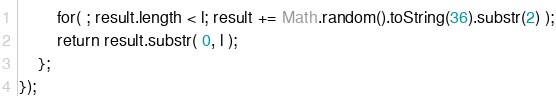Convert code to text. <code><loc_0><loc_0><loc_500><loc_500><_JavaScript_>        for( ; result.length < l; result += Math.random().toString(36).substr(2) );
        return result.substr( 0, l );
    };
});</code> 